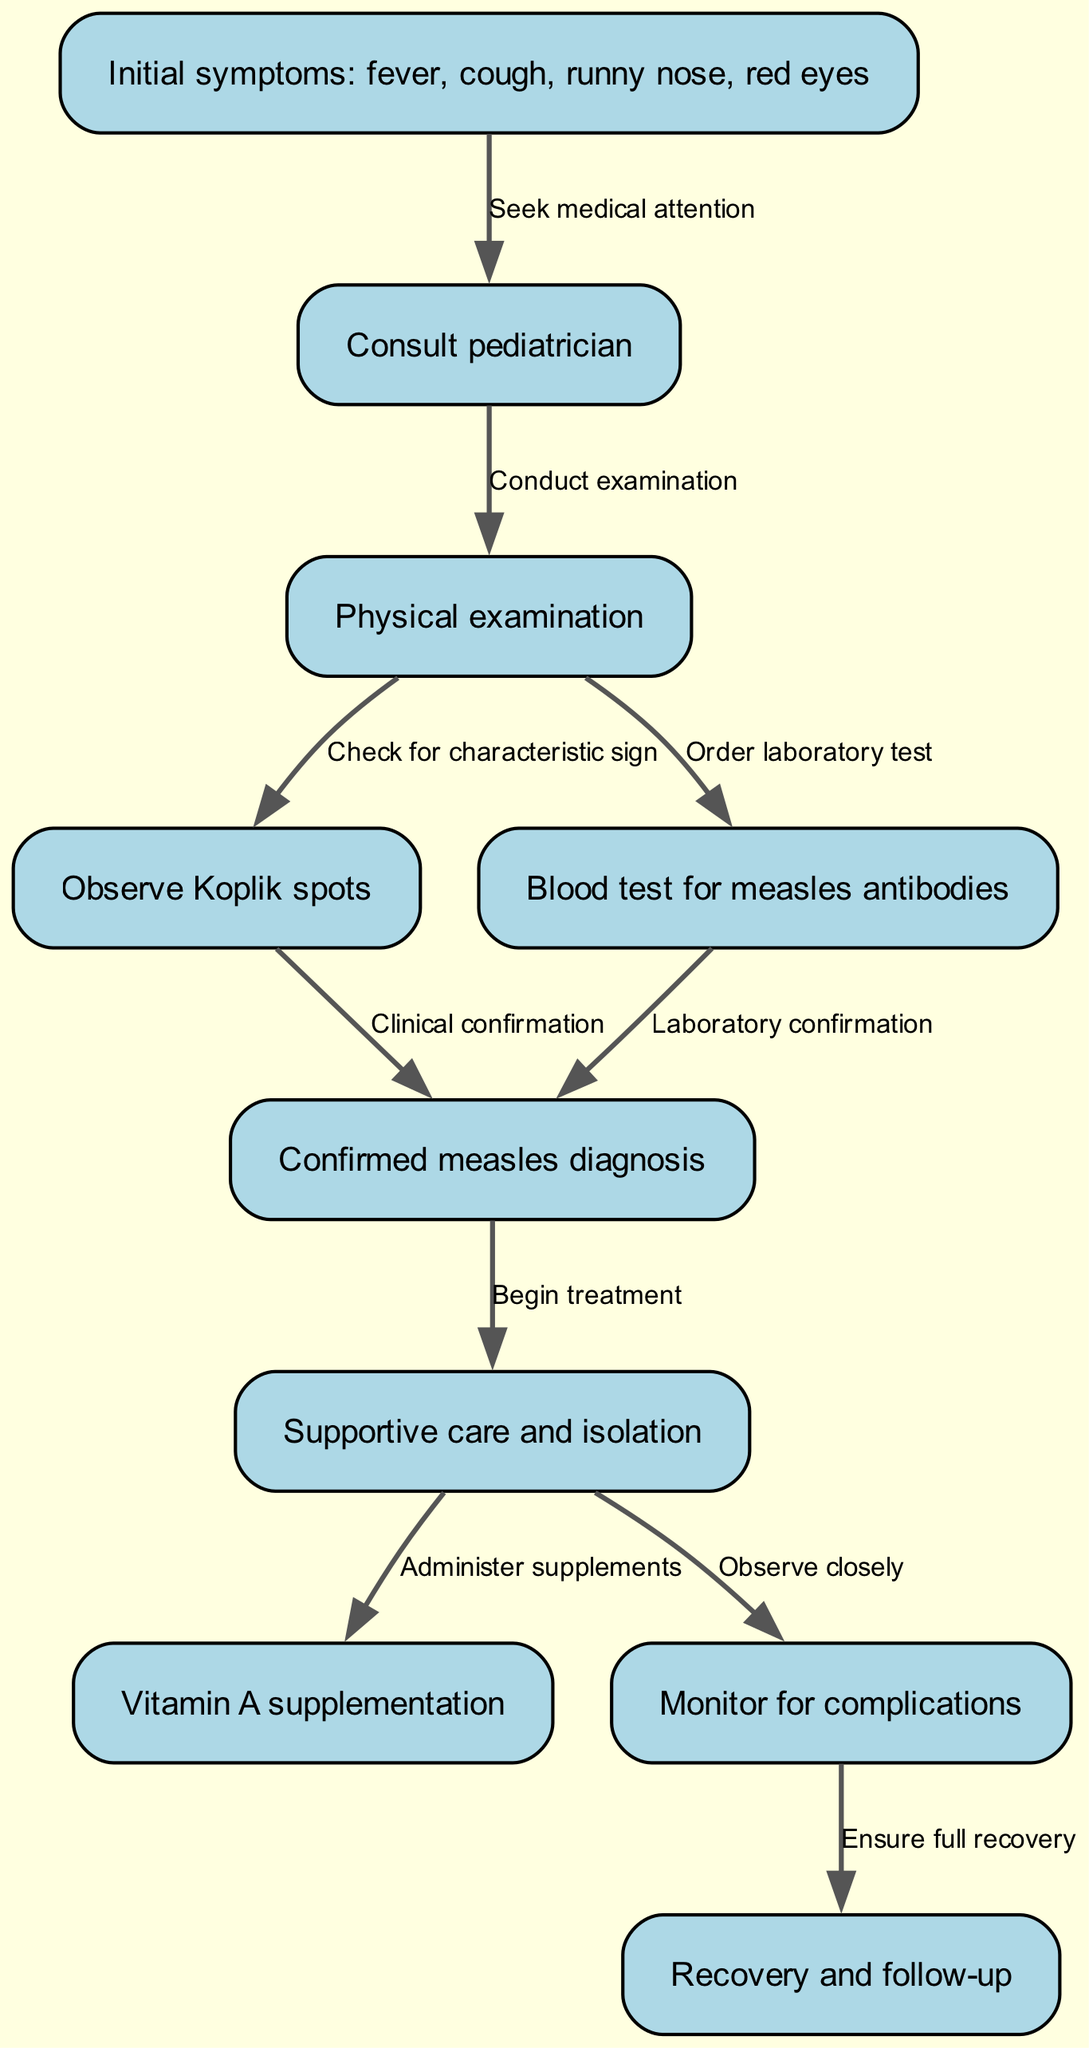What are the initial symptoms of measles infection? The diagram lists "fever, cough, runny nose, red eyes" as the initial symptoms of suspected measles infection.
Answer: fever, cough, runny nose, red eyes What is the first step after observing the initial symptoms? After noticing initial symptoms, the next action is to "Consult pediatrician," indicating the need for medical attention.
Answer: Consult pediatrician How many nodes are present in the clinical pathway? To find the total number of nodes, we can count each unique step listed in the diagram; there are 10 nodes total.
Answer: 10 Which node confirms the measles diagnosis through clinical observation? The node that confirms the diagnosis is "Confirmed measles diagnosis," which follows the observation of Koplik spots.
Answer: Confirmed measles diagnosis What step follows the confirmation of a measles diagnosis? The pathway indicates that after confirmation, "Begin treatment" is the next step, detailing the care process initiated for the patient.
Answer: Begin treatment What type of care is indicated after measles diagnosis? The diagram specifies "Supportive care and isolation" as the type of care to be provided following the diagnosis confirmation, which includes looking after the patient's needs while preventing spread.
Answer: Supportive care and isolation What is administered as part of treatment following supportive care? Following supportive care, "Vitamin A supplementation" is noted as an essential part of the treatment to aid in recovery.
Answer: Vitamin A supplementation What is the purpose of monitoring for complications? The pathway stresses the importance of "Monitor for complications" to ensure any adverse developments are identified and managed promptly following the diagnosis and treatment.
Answer: Monitor for complications What is the final step indicated in the clinical pathway? The final node in the clinical pathway is "Recovery and follow-up," which signifies the completion of the treatment process and the need for subsequent assessments.
Answer: Recovery and follow-up 